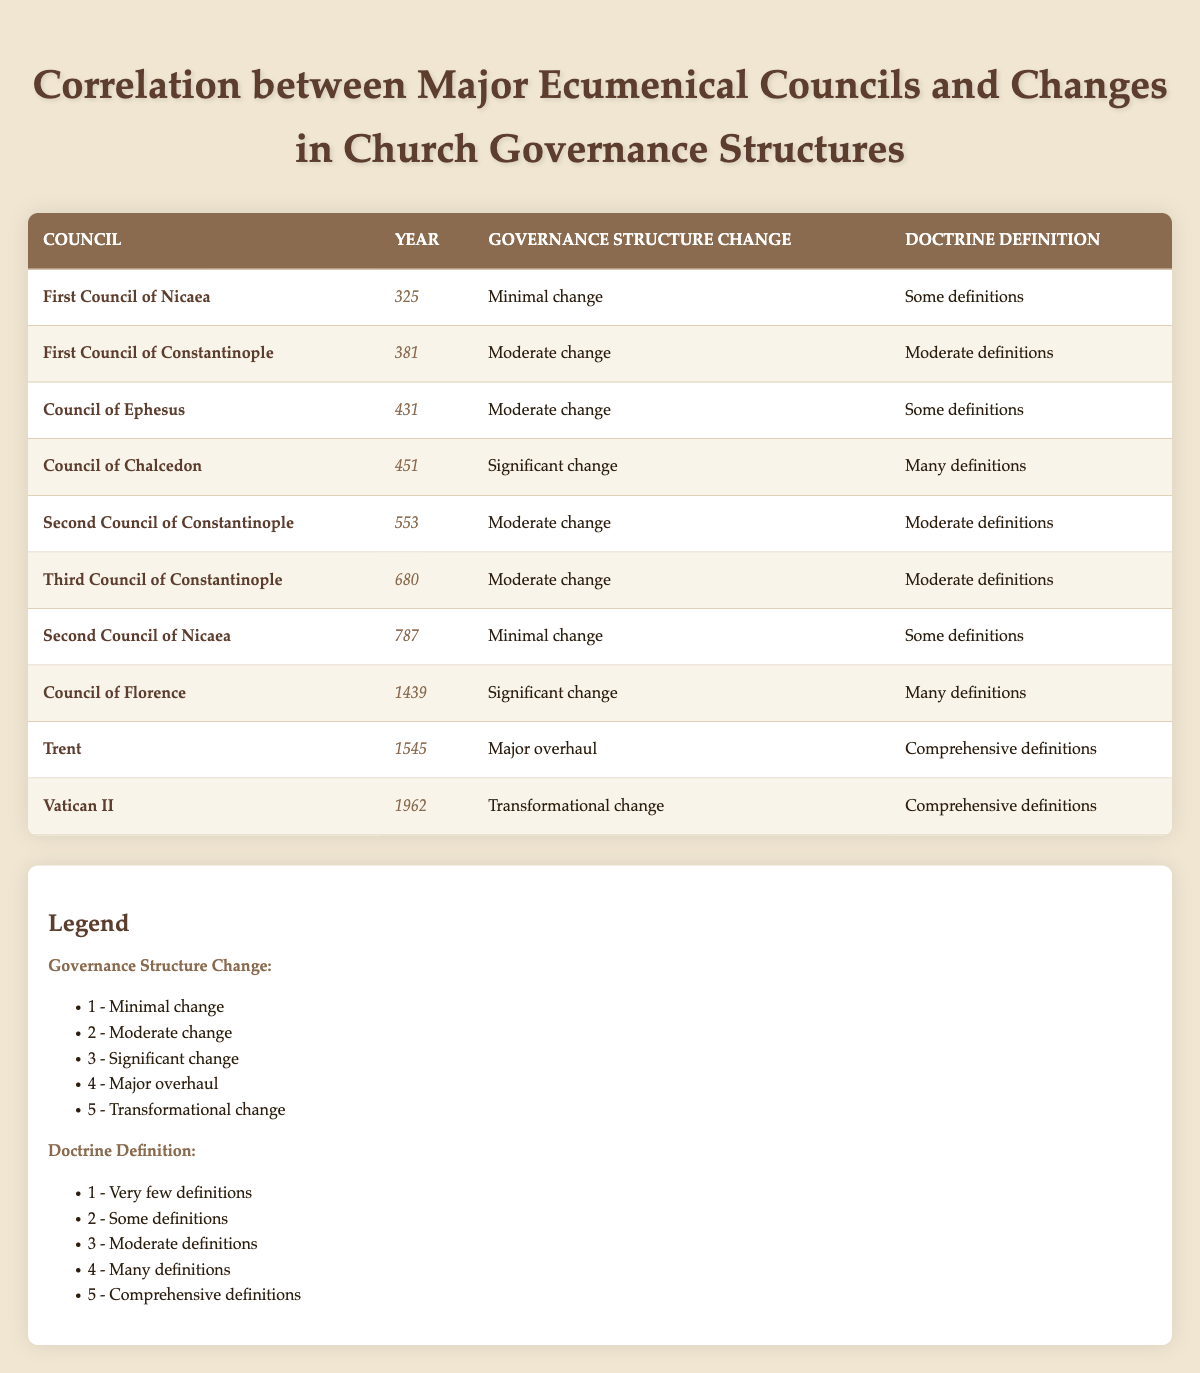What was the governance structure change at the Council of Chalcedon? According to the table, the Council of Chalcedon, which took place in 451, had a governance structure change categorized as "Significant change."
Answer: Significant change Which council had a transformational change in governance structure? The table indicates that Vatican II, held in 1962, experienced a "Transformational change" in governance structure.
Answer: Vatican II What is the average number of doctrine definitions for councils that had a significant or more profound change in governance structure? The relevant councils are the Council of Chalcedon (4), Council of Florence (4), Trent (5), and Vatican II (5). Adding these gives us 4 + 4 + 5 + 5 = 18, and there are 4 councils, so the average is 18/4 = 4.5.
Answer: 4.5 Were council decisions from the First Council of Nicaea characterized by many definitions? The table shows that the First Council of Nicaea had "Some definitions," not "Many definitions." Therefore, the statement is false.
Answer: No How many councils had a governance structure change categorized as moderate? By examining the table, we find three councils identified with a moderate change: First Council of Constantinople, Council of Ephesus, and Second Council of Constantinople.
Answer: Three councils What was the year of the council that resulted in a major overhaul of the governance structure? According to the table, the Council of Trent, which took place in 1545, resulted in a "Major overhaul" of governance structure.
Answer: 1545 Did the Second Council of Nicaea have a significant change in governance structure? The table indicates that the Second Council of Nicaea had a governance structure change classified as "Minimal change," so the statement is false.
Answer: No Count the number of councils listed in the table that had some level of doctrine definitions. The councils with some level of doctrine definitions are First Council of Nicaea, Council of Ephesus, Second Council of Nicaea, and Second Council of Constantinople. This totals four councils.
Answer: Four councils 